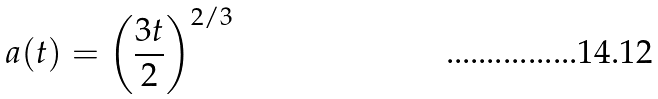Convert formula to latex. <formula><loc_0><loc_0><loc_500><loc_500>a ( t ) = \left ( \frac { 3 t } { 2 } \right ) ^ { 2 / 3 }</formula> 